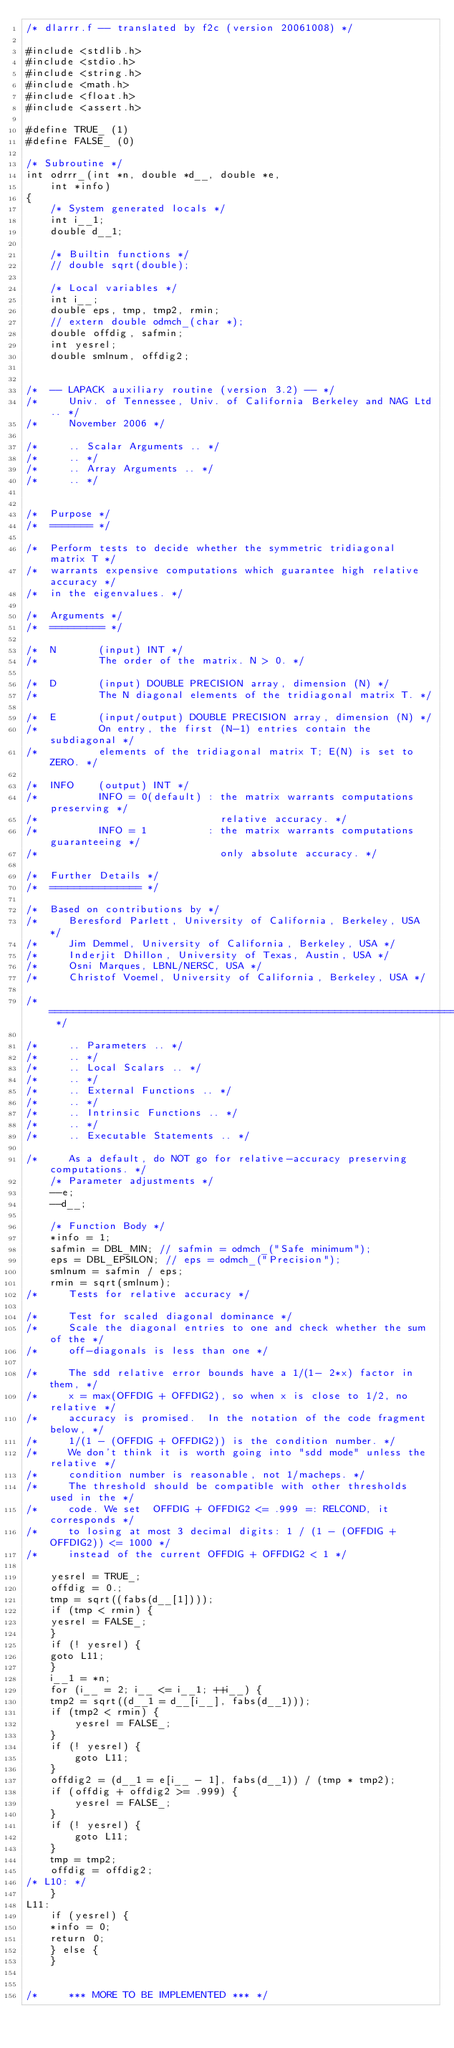Convert code to text. <code><loc_0><loc_0><loc_500><loc_500><_C_>/* dlarrr.f -- translated by f2c (version 20061008) */

#include <stdlib.h>
#include <stdio.h>
#include <string.h>
#include <math.h>
#include <float.h>
#include <assert.h>

#define TRUE_ (1)
#define FALSE_ (0)

/* Subroutine */ 
int odrrr_(int *n, double *d__, double *e, 
	int *info)
{
    /* System generated locals */
    int i__1;
    double d__1;

    /* Builtin functions */
    // double sqrt(double);

    /* Local variables */
    int i__;
    double eps, tmp, tmp2, rmin;
    // extern double odmch_(char *);
    double offdig, safmin;
    int yesrel;
    double smlnum, offdig2;


/*  -- LAPACK auxiliary routine (version 3.2) -- */
/*     Univ. of Tennessee, Univ. of California Berkeley and NAG Ltd.. */
/*     November 2006 */

/*     .. Scalar Arguments .. */
/*     .. */
/*     .. Array Arguments .. */
/*     .. */


/*  Purpose */
/*  ======= */

/*  Perform tests to decide whether the symmetric tridiagonal matrix T */
/*  warrants expensive computations which guarantee high relative accuracy */
/*  in the eigenvalues. */

/*  Arguments */
/*  ========= */

/*  N       (input) INT */
/*          The order of the matrix. N > 0. */

/*  D       (input) DOUBLE PRECISION array, dimension (N) */
/*          The N diagonal elements of the tridiagonal matrix T. */

/*  E       (input/output) DOUBLE PRECISION array, dimension (N) */
/*          On entry, the first (N-1) entries contain the subdiagonal */
/*          elements of the tridiagonal matrix T; E(N) is set to ZERO. */

/*  INFO    (output) INT */
/*          INFO = 0(default) : the matrix warrants computations preserving */
/*                              relative accuracy. */
/*          INFO = 1          : the matrix warrants computations guaranteeing */
/*                              only absolute accuracy. */

/*  Further Details */
/*  =============== */

/*  Based on contributions by */
/*     Beresford Parlett, University of California, Berkeley, USA */
/*     Jim Demmel, University of California, Berkeley, USA */
/*     Inderjit Dhillon, University of Texas, Austin, USA */
/*     Osni Marques, LBNL/NERSC, USA */
/*     Christof Voemel, University of California, Berkeley, USA */

/*  ===================================================================== */

/*     .. Parameters .. */
/*     .. */
/*     .. Local Scalars .. */
/*     .. */
/*     .. External Functions .. */
/*     .. */
/*     .. Intrinsic Functions .. */
/*     .. */
/*     .. Executable Statements .. */

/*     As a default, do NOT go for relative-accuracy preserving computations. */
    /* Parameter adjustments */
    --e;
    --d__;

    /* Function Body */
    *info = 1;
    safmin = DBL_MIN; // safmin = odmch_("Safe minimum");
    eps = DBL_EPSILON; // eps = odmch_("Precision");
    smlnum = safmin / eps;
    rmin = sqrt(smlnum);
/*     Tests for relative accuracy */

/*     Test for scaled diagonal dominance */
/*     Scale the diagonal entries to one and check whether the sum of the */
/*     off-diagonals is less than one */

/*     The sdd relative error bounds have a 1/(1- 2*x) factor in them, */
/*     x = max(OFFDIG + OFFDIG2), so when x is close to 1/2, no relative */
/*     accuracy is promised.  In the notation of the code fragment below, */
/*     1/(1 - (OFFDIG + OFFDIG2)) is the condition number. */
/*     We don't think it is worth going into "sdd mode" unless the relative */
/*     condition number is reasonable, not 1/macheps. */
/*     The threshold should be compatible with other thresholds used in the */
/*     code. We set  OFFDIG + OFFDIG2 <= .999 =: RELCOND, it corresponds */
/*     to losing at most 3 decimal digits: 1 / (1 - (OFFDIG + OFFDIG2)) <= 1000 */
/*     instead of the current OFFDIG + OFFDIG2 < 1 */

    yesrel = TRUE_;
    offdig = 0.;
    tmp = sqrt((fabs(d__[1])));
    if (tmp < rmin) {
	yesrel = FALSE_;
    }
    if (! yesrel) {
	goto L11;
    }
    i__1 = *n;
    for (i__ = 2; i__ <= i__1; ++i__) {
	tmp2 = sqrt((d__1 = d__[i__], fabs(d__1)));
	if (tmp2 < rmin) {
	    yesrel = FALSE_;
	}
	if (! yesrel) {
	    goto L11;
	}
	offdig2 = (d__1 = e[i__ - 1], fabs(d__1)) / (tmp * tmp2);
	if (offdig + offdig2 >= .999) {
	    yesrel = FALSE_;
	}
	if (! yesrel) {
	    goto L11;
	}
	tmp = tmp2;
	offdig = offdig2;
/* L10: */
    }
L11:
    if (yesrel) {
	*info = 0;
	return 0;
    } else {
    }


/*     *** MORE TO BE IMPLEMENTED *** */

</code> 